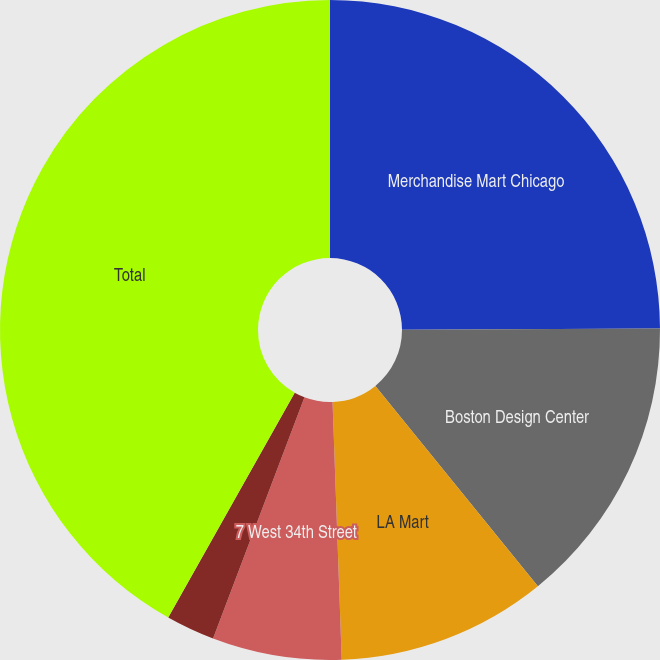Convert chart. <chart><loc_0><loc_0><loc_500><loc_500><pie_chart><fcel>Merchandise Mart Chicago<fcel>Boston Design Center<fcel>LA Mart<fcel>7 West 34th Street<fcel>Washington Design Center<fcel>Total<nl><fcel>24.93%<fcel>14.22%<fcel>10.28%<fcel>6.33%<fcel>2.39%<fcel>41.84%<nl></chart> 